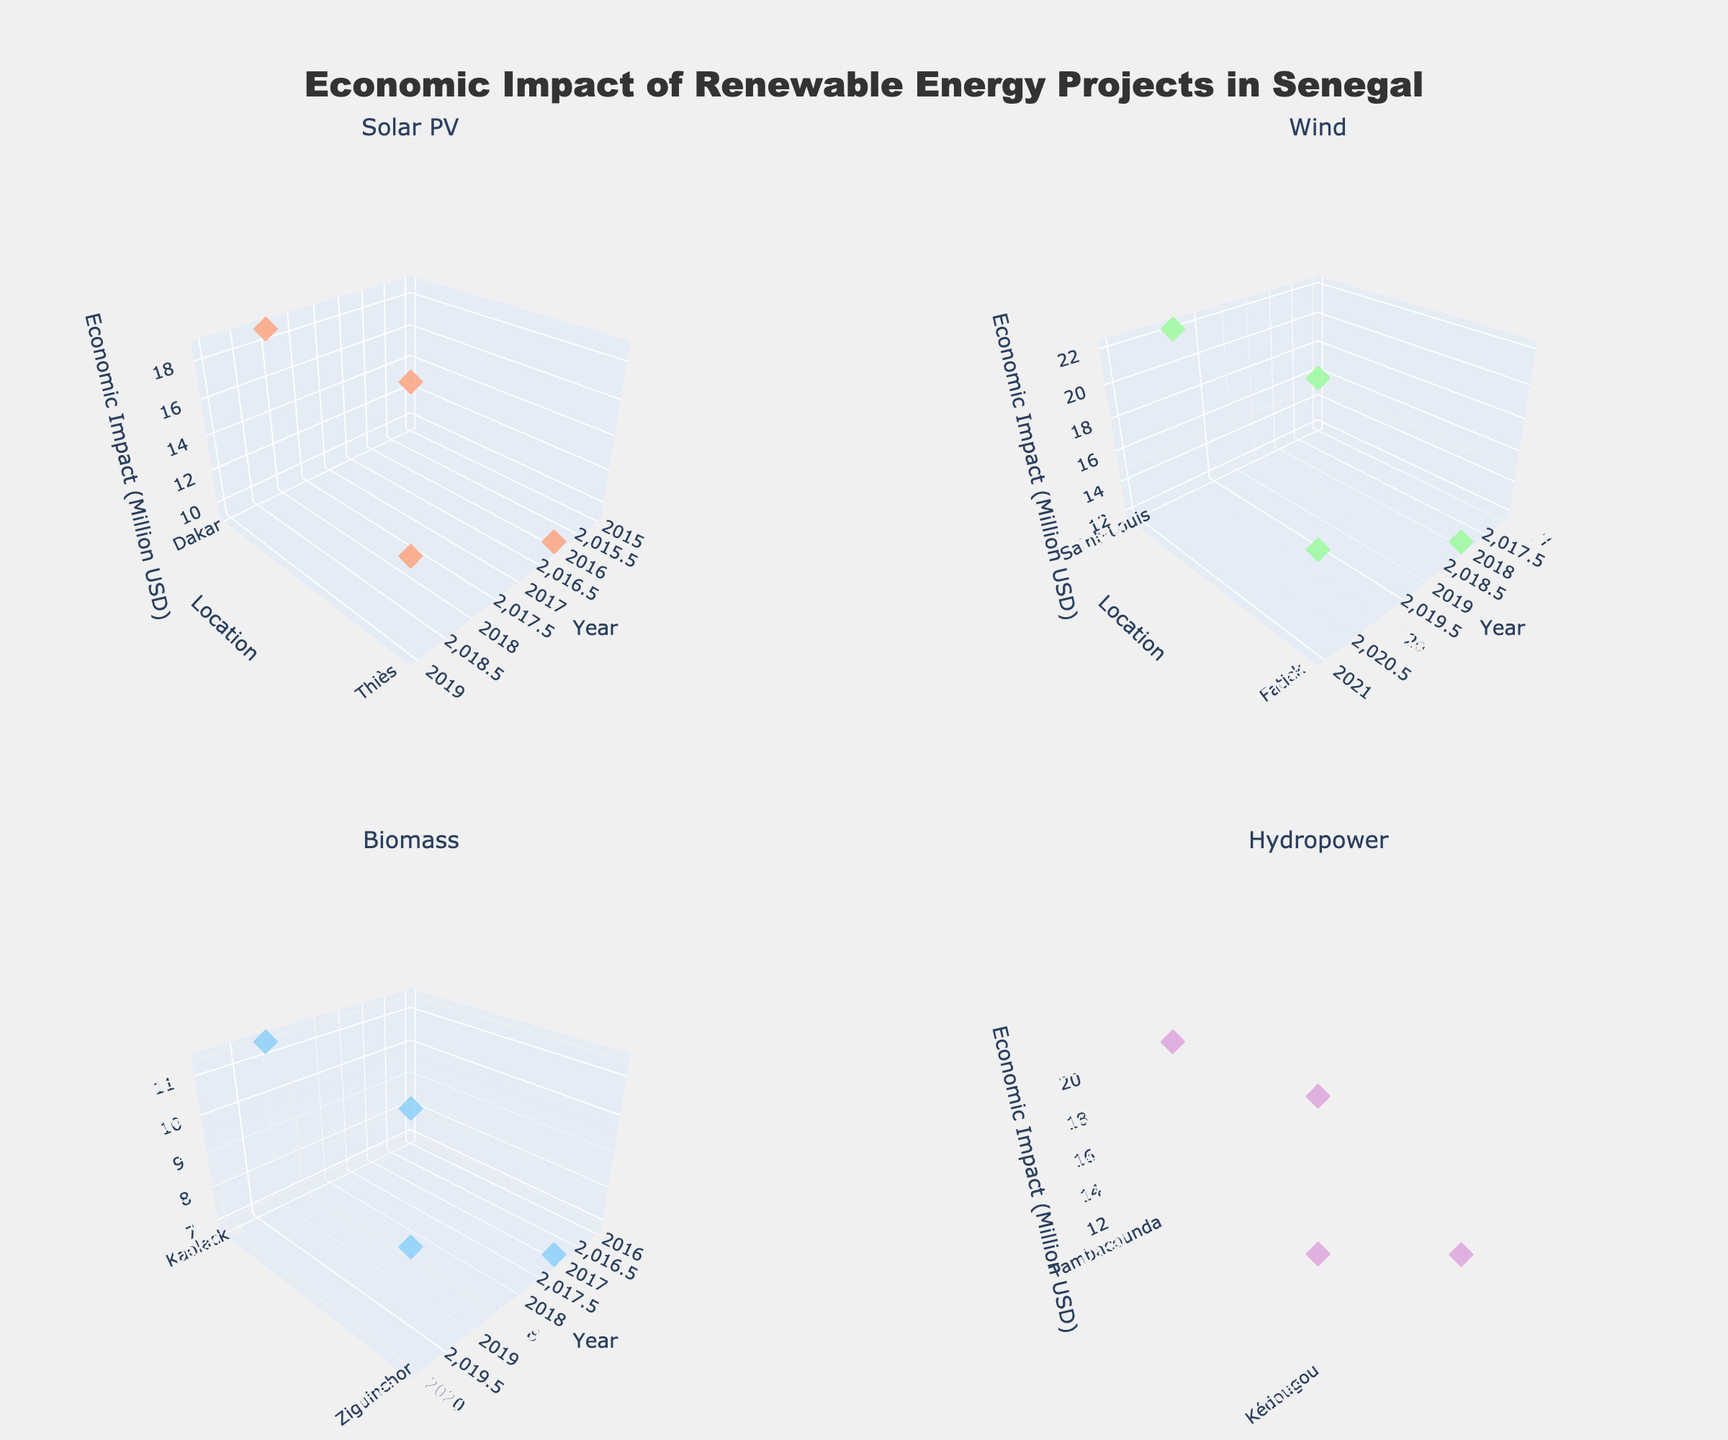How many project types are displayed in the figure? The figure displays four subplots, each representing a different project type. The subplot titles indicate the project types.
Answer: 4 Which project type and location combination had the highest economic impact? To find this, we need to look at the highest z-value (economic impact) in all subplots and check its corresponding project type and location. The Wind project in Saint-Louis in 2020 has the highest economic impact of 22.1 Million USD.
Answer: Wind in Saint-Louis What is the economic impact range of Biomass projects from 2016 to 2020? Check the Biomass subplot for the minimum and maximum z-values (economic impact) between 2016 and 2020. In 2016, it is 7.9 Million USD, and in 2020, it is 9.7 Million USD.
Answer: 7.9 to 9.7 Million USD Which location had the earliest implementation of a Hydropower project, and what was the economic impact? Look at the Hydropower subplot and check the earliest year on the x-axis. Tambacounda had projects starting in 2015 with an economic impact of 14.3 Million USD.
Answer: Tambacounda and 14.3 Million USD Compare the economic impact of Solar PV projects in Dakar and Thiès in their latest implementation years. Which was higher? Check the Solar PV subplot for the latest implementation years in Dakar and Thiès. Dakar in 2018 had 18.7 Million USD, and Thiès in 2019 had 14.2 Million USD.
Answer: Dakar Which year saw the most diverse implementation across all project types and what were the locations? Scan all subplots for the year with the highest number of distinct projects. The year 2016 saw projects across Solar PV in Thiès, Biomass in Kaolack, and Hydropower in Kédougou.
Answer: 2016 and Thiès, Kaolack, Kédougou What is the average economic impact of Wind projects implemented in Fatick? There are Wind projects in Fatick implemented in 2018 and 2021 with impacts of 11.8 and 17.5 Million USD, respectively. The average is (11.8 + 17.5) / 2.
Answer: 14.65 Million USD By how much did the economic impact of Hydropower projects in Kédougou increase from 2016 to 2019? Subtract the economic impact value in 2016 from the value in 2019. 16.8 - 11.2 = 5.6 Million USD.
Answer: 5.6 Million USD In which year did Biomass projects in Kaolack see their highest economic impact and what was the value? Check the Biomass subplot for Kaolack's economic impacts. The highest impact was in 2019 with 11.4 Million USD.
Answer: 2019 and 11.4 Million USD Which location had no Solar PV projects implemented throughout the described years? Verify each location across all project types. Kaolack and Ziguinchor have only Biomass projects, and neither has Solar PV projects.
Answer: Kaolack and Ziguinchor 